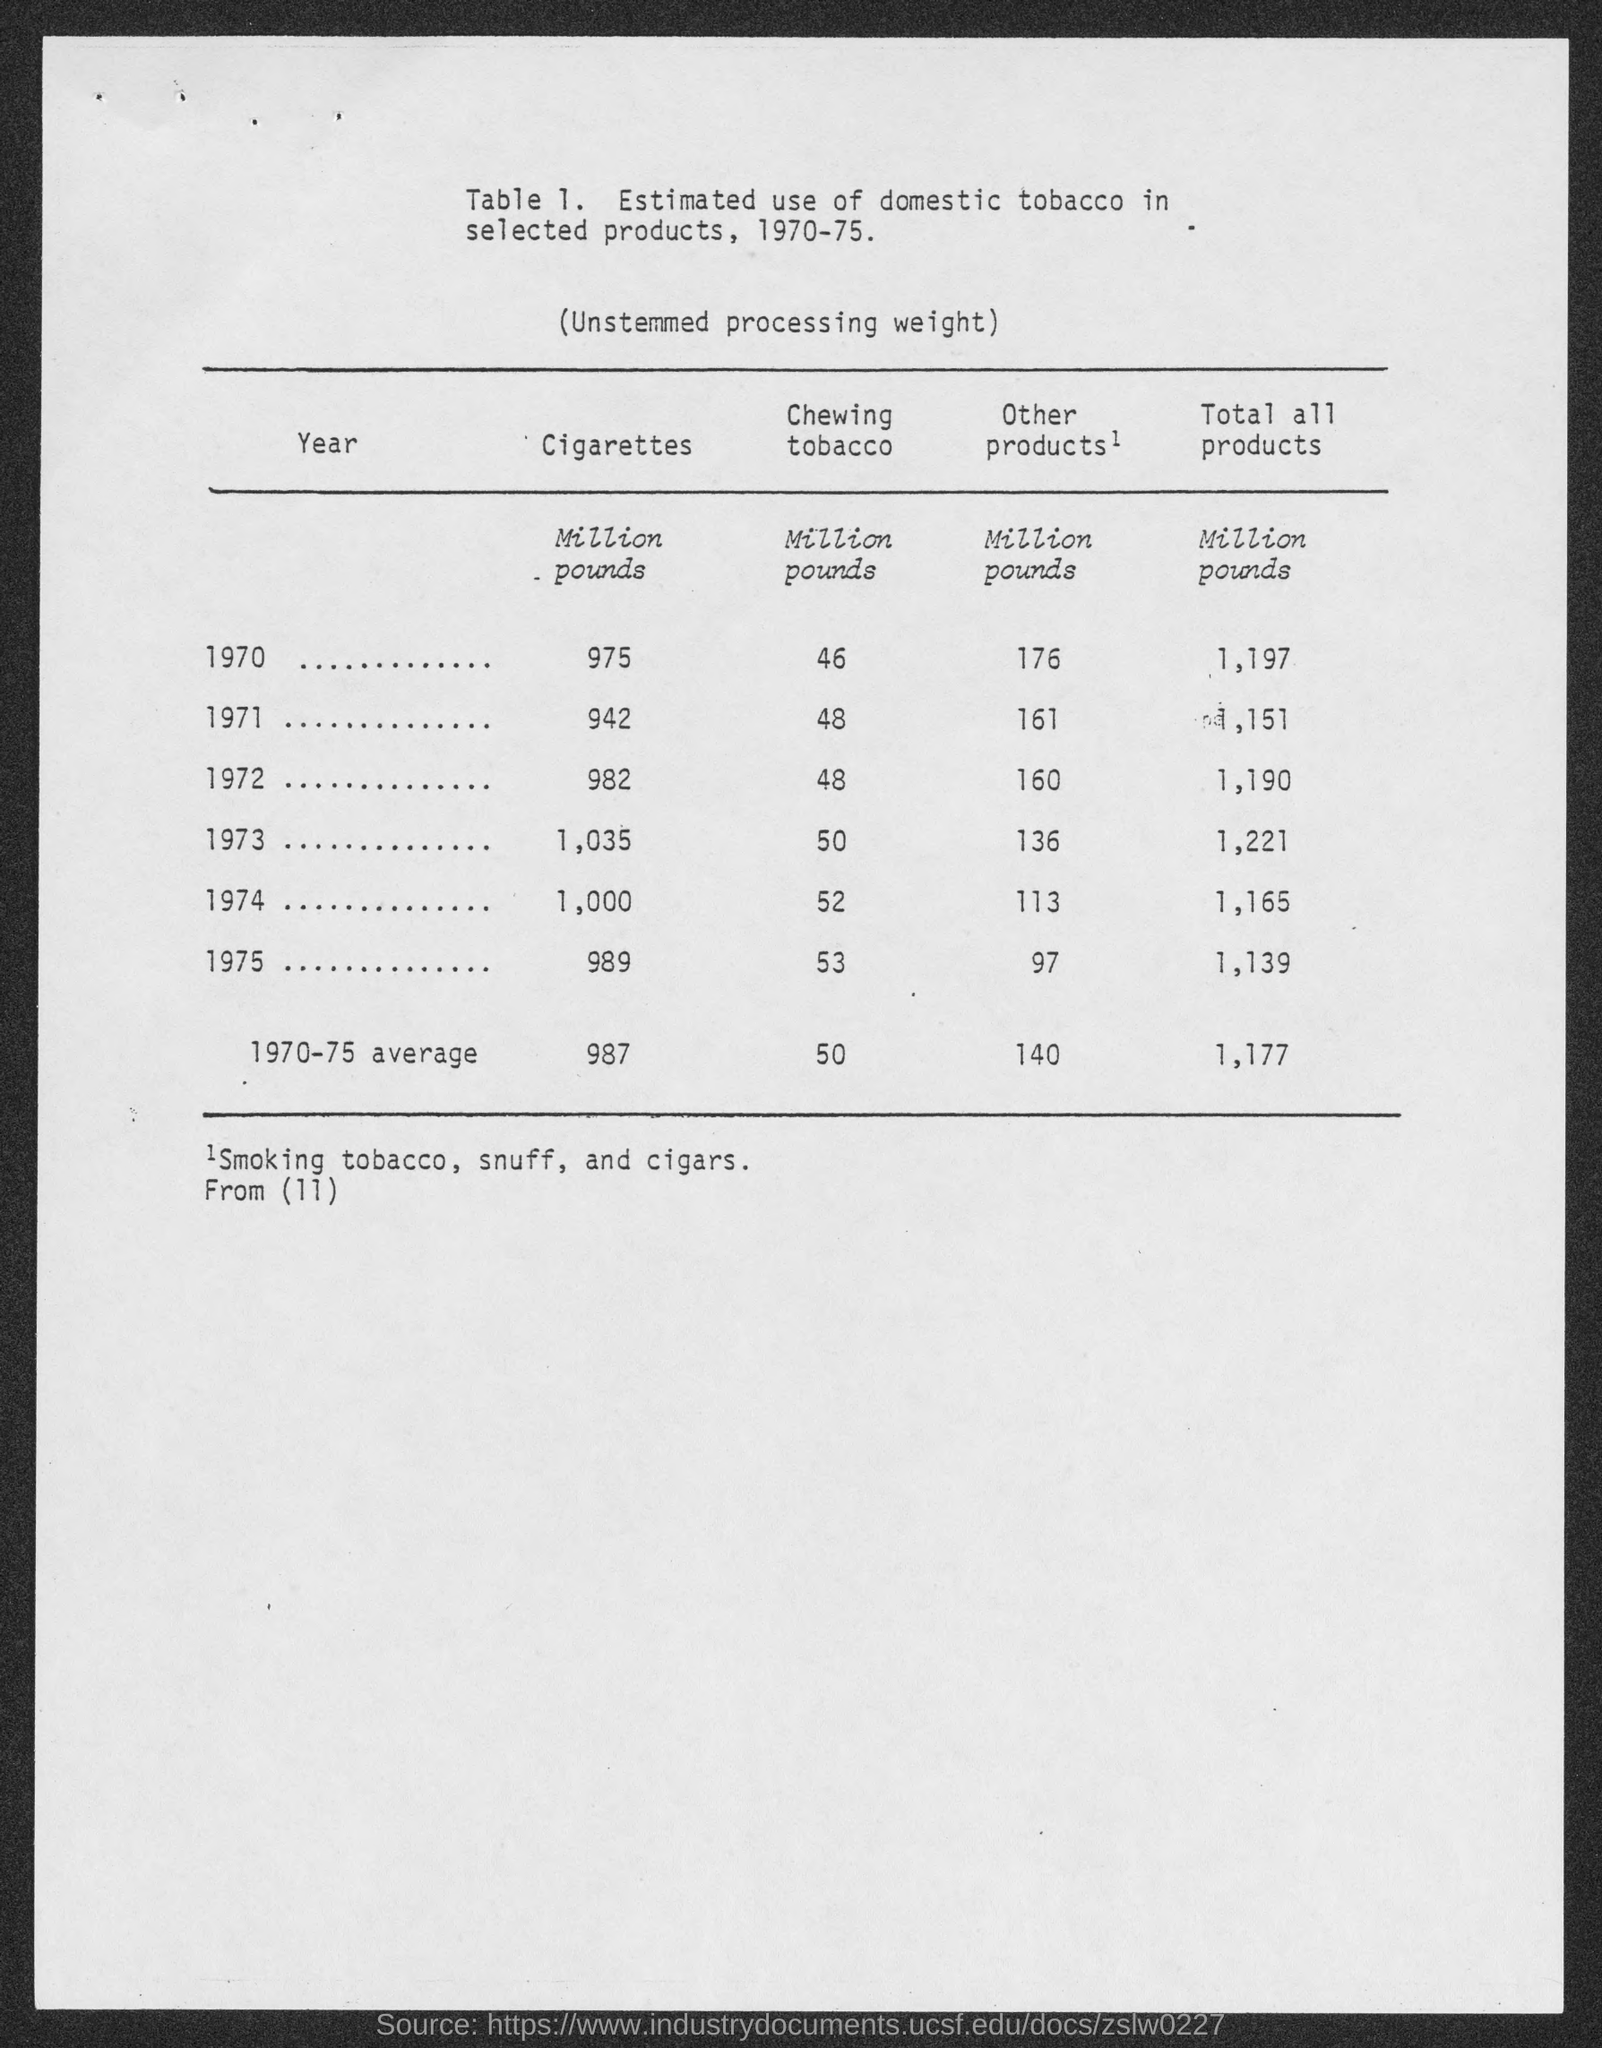Highlight a few significant elements in this photo. The title of the table shows a range of years from 1970 to 1975. The third row from the top represents the year 1972. In the year 1971, an estimated 48 million pounds of chewing tobacco was used. According to estimates, approximately 136 million pounds of "Other products" are expected to be used in the year 1973. The first column heading is labeled as 'YEAR,' indicating that it represents the year of the data in the table. 